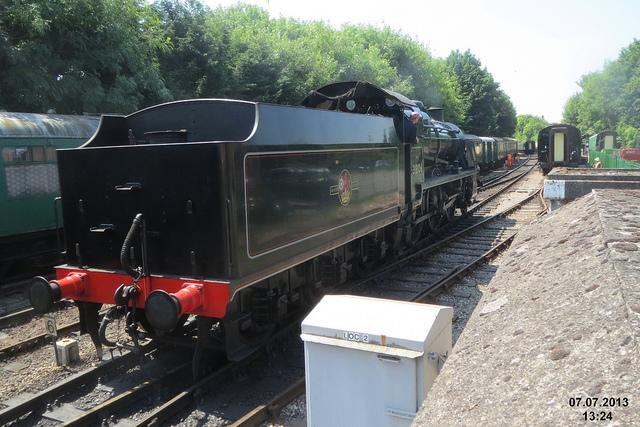The purpose of the train car behind the train engine is to hold what? Please explain your reasoning. coal. That train car holds the fuel for the engine. cargo and passengers are held in other cars. 